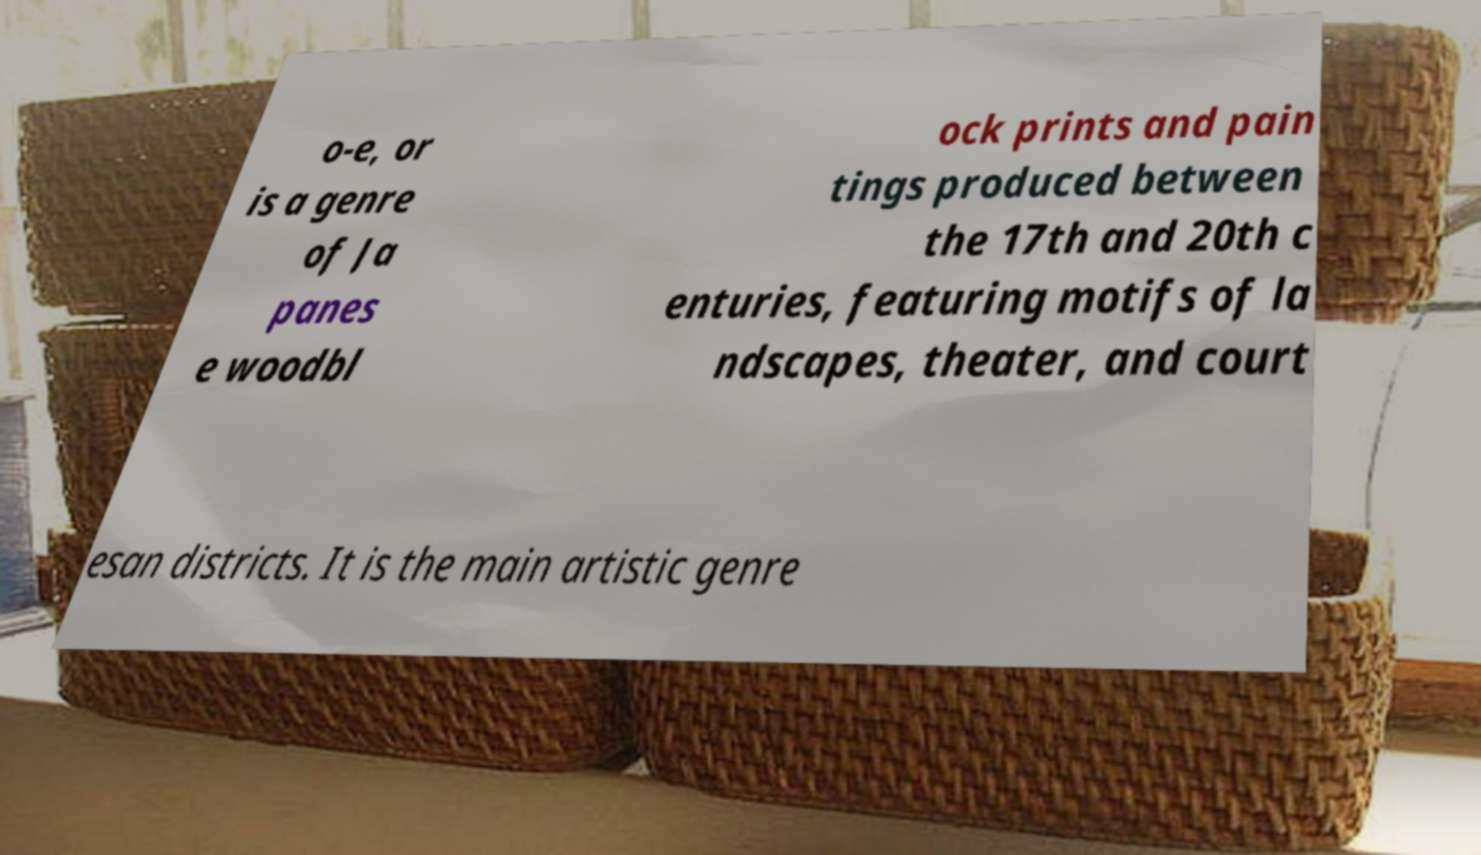Please identify and transcribe the text found in this image. o-e, or is a genre of Ja panes e woodbl ock prints and pain tings produced between the 17th and 20th c enturies, featuring motifs of la ndscapes, theater, and court esan districts. It is the main artistic genre 